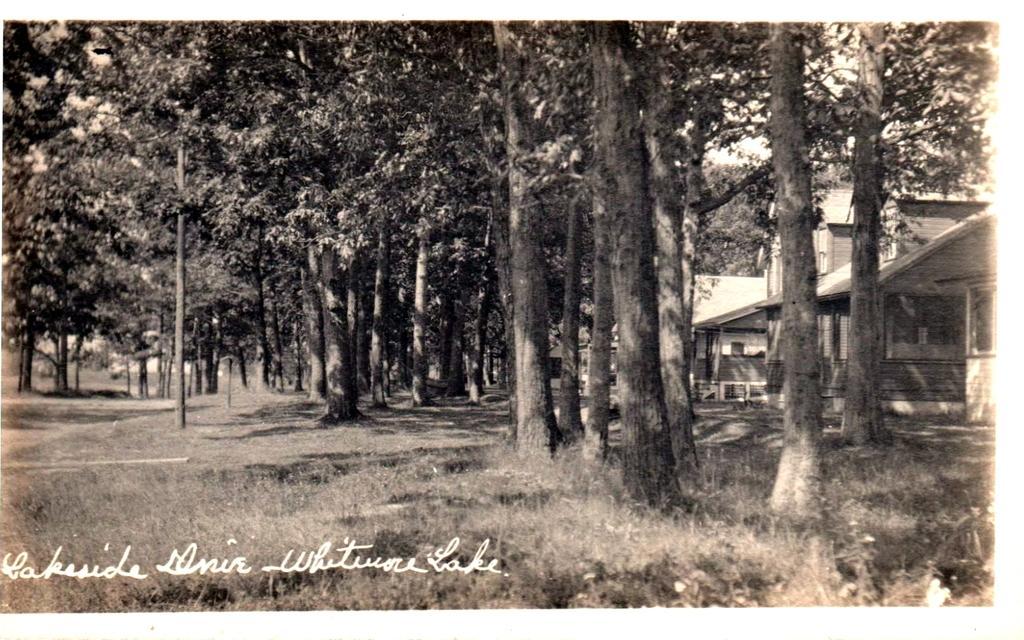How would you summarize this image in a sentence or two? It looks like an old black and white picture. We can see houses, trees and a sky. On the image there is a watermark. 